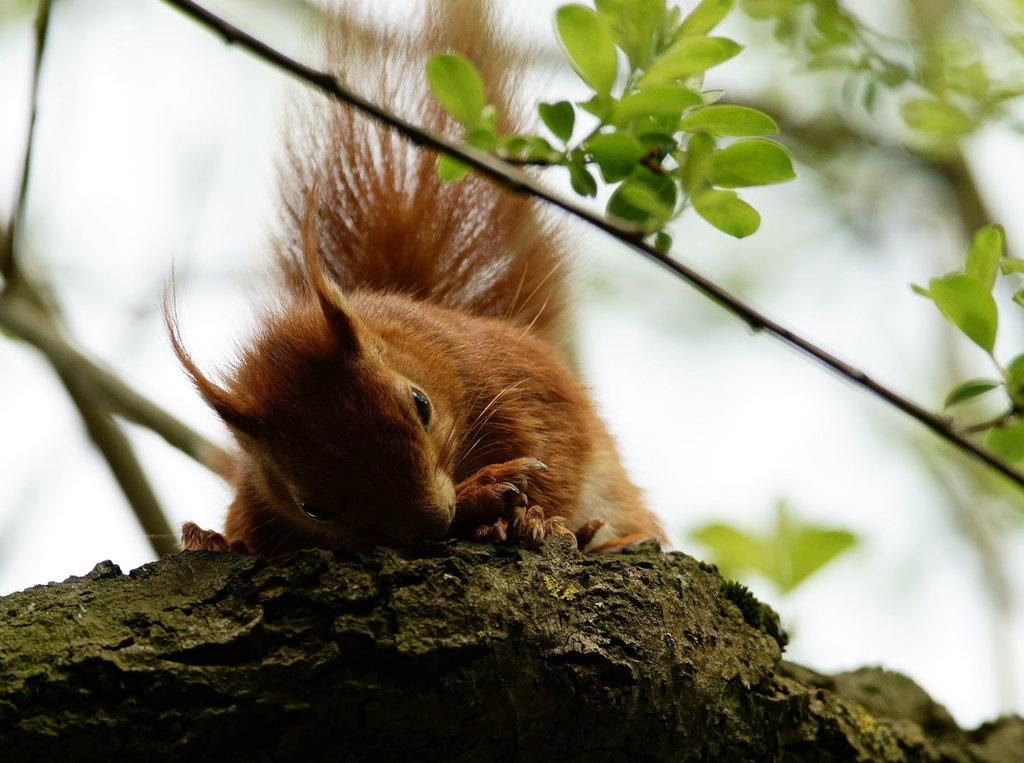What can be observed about the background of the image? The background portion of the picture is blurred. What type of vegetation is present in the image? There are green leaves in the image. What else is associated with the vegetation in the image? There are stems in the image. What animal is visible in the image? There is a squirrel in the image. Where is the squirrel located in the image? The squirrel is on a surface. What type of food is the squirrel eating in the image? There is no food visible in the image; the squirrel is not shown eating anything. 